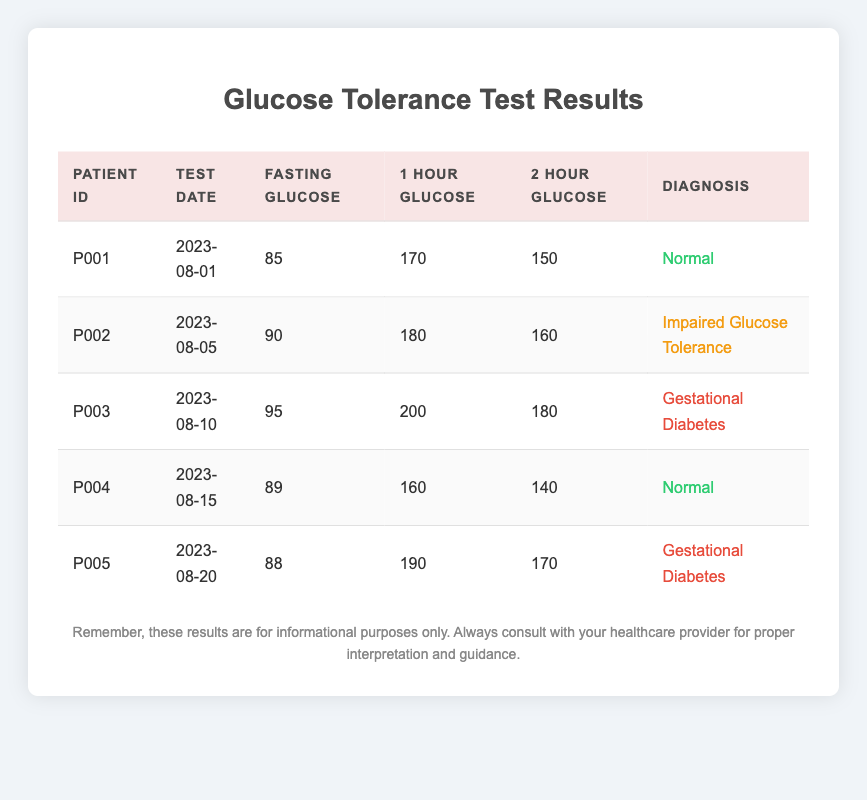What is the fasting glucose level for Patient P003? The table shows each patient's fasting glucose level. For Patient P003, the corresponding fasting glucose value is 95.
Answer: 95 What is the diagnosis of Patient P002? In the table, the diagnosis is listed in the last column for each patient. Patient P002 is diagnosed with "Impaired Glucose Tolerance."
Answer: Impaired Glucose Tolerance Which patient has the highest 1-hour glucose level? The table lists the 1-hour glucose levels for each patient. Comparing these, Patient P003 has the highest 1-hour glucose level at 200.
Answer: P003 What is the average fasting glucose level for all patients? To find the average fasting glucose level, add all fasting glucose values: 85 + 90 + 95 + 89 + 88 = 447. There are 5 patients, so the average is 447 / 5 = 89.4.
Answer: 89.4 Is there any patient diagnosed with "Gestational Diabetes"? The diagnosis column shows that both Patient P003 and Patient P005 are diagnosed with "Gestational Diabetes," confirming the statement is true.
Answer: Yes How many patients have a diagnosis of "Normal"? From the diagnosis column, Patient P001 and Patient P004 are diagnosed as "Normal," totaling 2 patients.
Answer: 2 Which patient had the glucose test on August 15, 2023? Looking at the test dates in the table, Patient P004 is the one who had the glucose test on August 15, 2023.
Answer: P004 What is the difference between the 2-hour glucose levels of Patients P003 and P005? For Patient P003, the 2-hour glucose level is 180, whereas for Patient P005, it is 170. Subtracting these: 180 - 170 = 10.
Answer: 10 How many patients have an impaired glucose tolerance level? From the diagnosis column, only Patient P002 is listed under "Impaired Glucose Tolerance," making the total 1 patient.
Answer: 1 